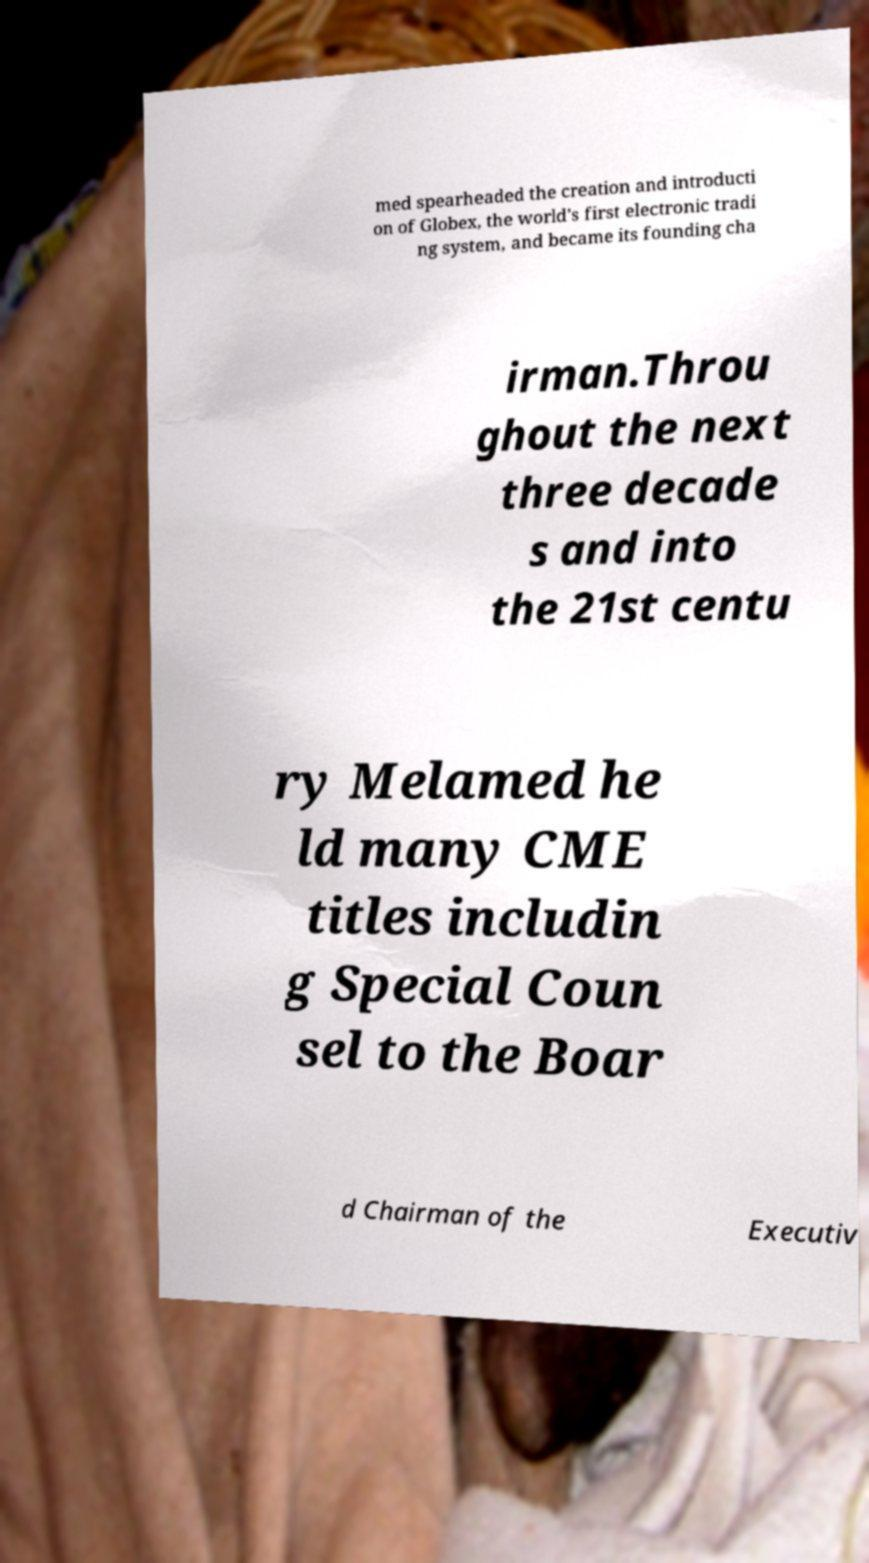I need the written content from this picture converted into text. Can you do that? med spearheaded the creation and introducti on of Globex, the world's first electronic tradi ng system, and became its founding cha irman.Throu ghout the next three decade s and into the 21st centu ry Melamed he ld many CME titles includin g Special Coun sel to the Boar d Chairman of the Executiv 